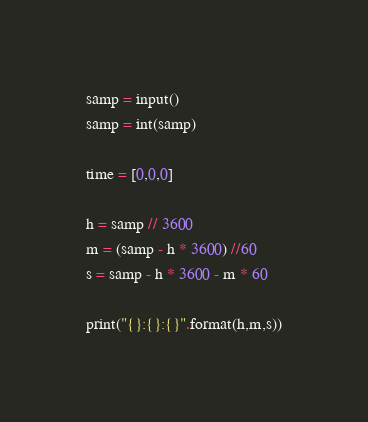<code> <loc_0><loc_0><loc_500><loc_500><_Python_>samp = input()
samp = int(samp)

time = [0,0,0]

h = samp // 3600
m = (samp - h * 3600) //60
s = samp - h * 3600 - m * 60

print("{}:{}:{}".format(h,m,s))
</code> 